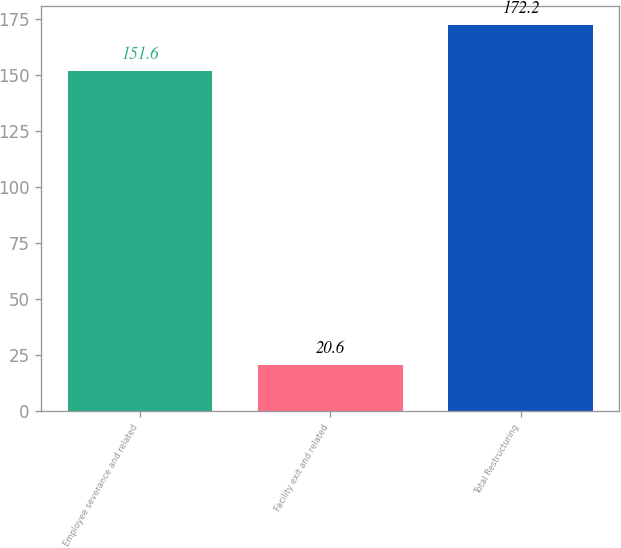Convert chart. <chart><loc_0><loc_0><loc_500><loc_500><bar_chart><fcel>Employee severance and related<fcel>Facility exit and related<fcel>Total Restructuring<nl><fcel>151.6<fcel>20.6<fcel>172.2<nl></chart> 